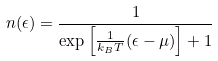Convert formula to latex. <formula><loc_0><loc_0><loc_500><loc_500>n ( \epsilon ) = \frac { 1 } { \exp \left [ \frac { 1 } { k _ { B } T } ( \epsilon - \mu ) \right ] + 1 }</formula> 